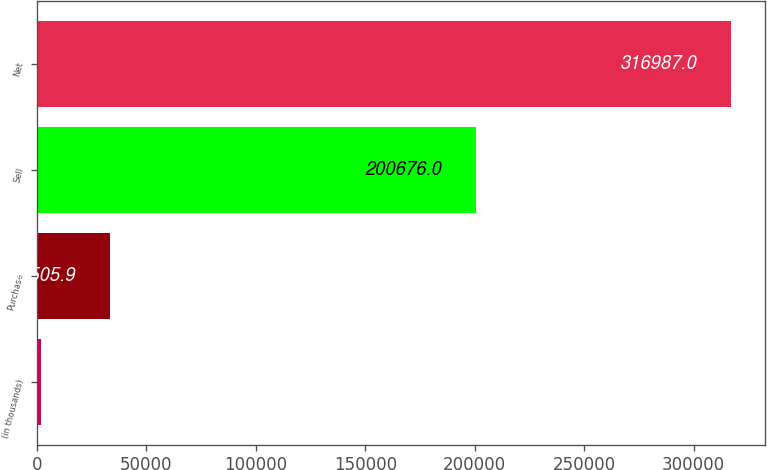<chart> <loc_0><loc_0><loc_500><loc_500><bar_chart><fcel>(in thousands)<fcel>Purchase<fcel>Sell<fcel>Net<nl><fcel>2008<fcel>33505.9<fcel>200676<fcel>316987<nl></chart> 